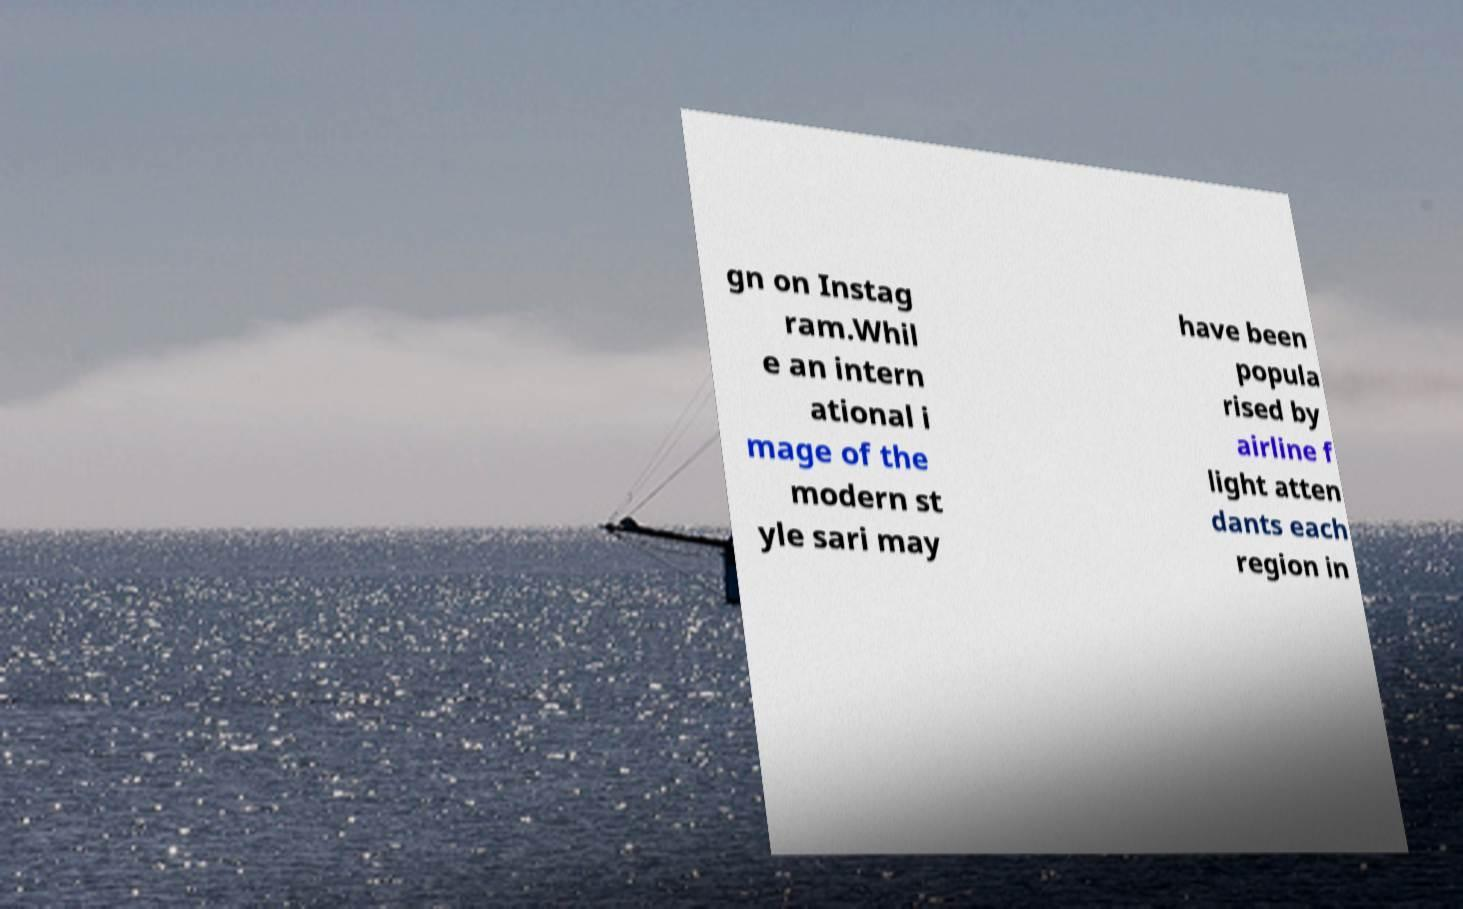Can you read and provide the text displayed in the image?This photo seems to have some interesting text. Can you extract and type it out for me? gn on Instag ram.Whil e an intern ational i mage of the modern st yle sari may have been popula rised by airline f light atten dants each region in 